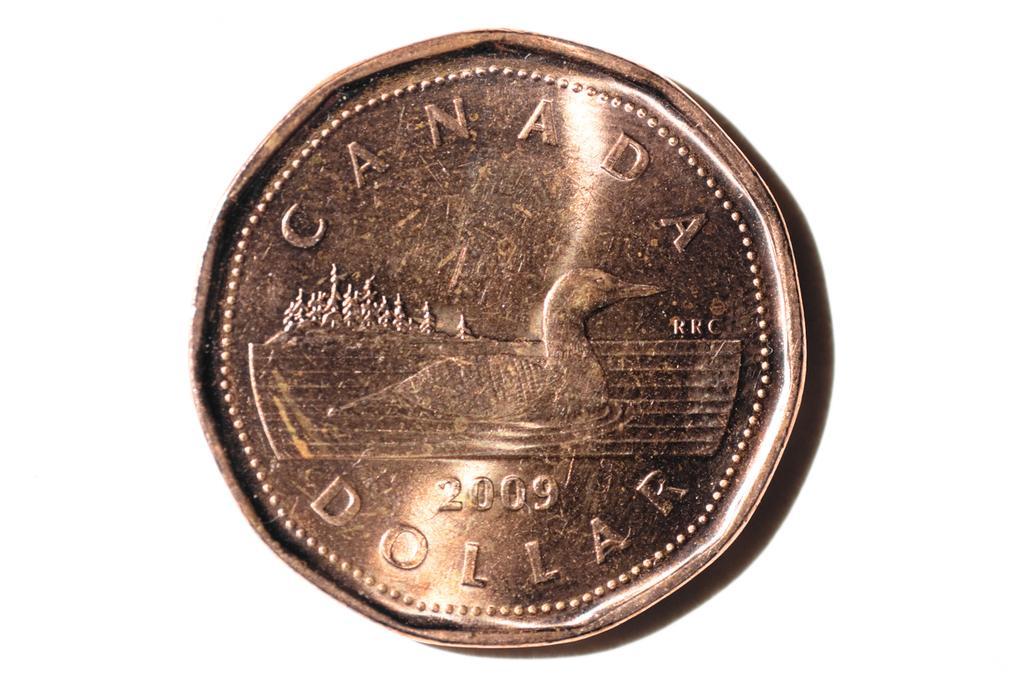Describe this image in one or two sentences. In this image there is a coin on which there is a text and image of a bird, numbers, background is white. 